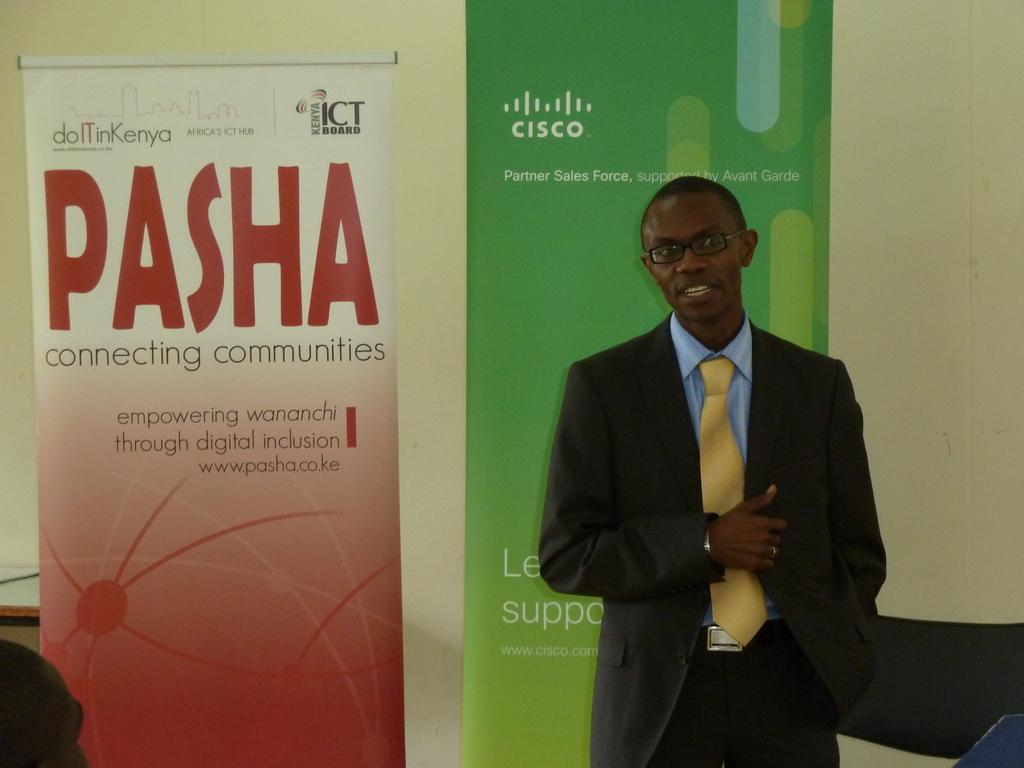Provide a one-sentence caption for the provided image. Join a PASHA meeting and start connecting communities. 